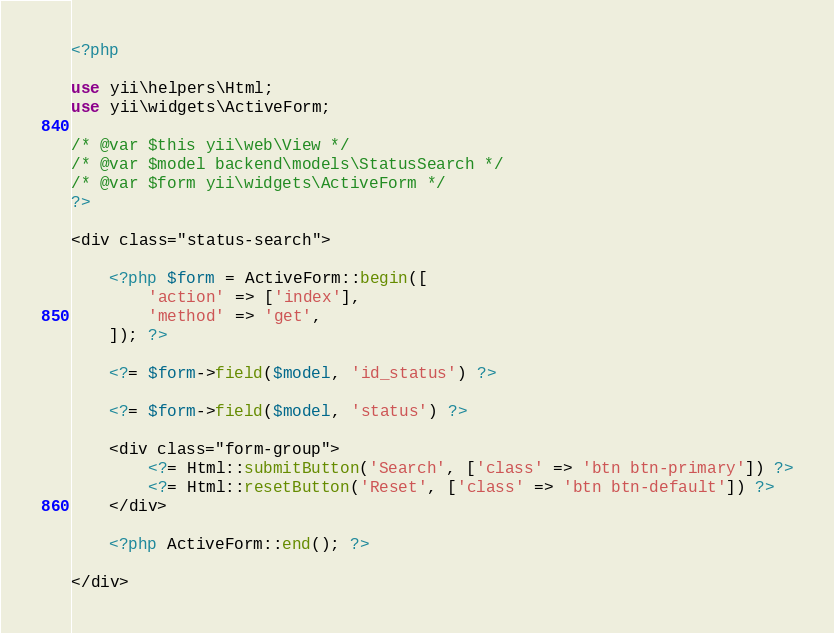Convert code to text. <code><loc_0><loc_0><loc_500><loc_500><_PHP_><?php

use yii\helpers\Html;
use yii\widgets\ActiveForm;

/* @var $this yii\web\View */
/* @var $model backend\models\StatusSearch */
/* @var $form yii\widgets\ActiveForm */
?>

<div class="status-search">

    <?php $form = ActiveForm::begin([
        'action' => ['index'],
        'method' => 'get',
    ]); ?>

    <?= $form->field($model, 'id_status') ?>

    <?= $form->field($model, 'status') ?>

    <div class="form-group">
        <?= Html::submitButton('Search', ['class' => 'btn btn-primary']) ?>
        <?= Html::resetButton('Reset', ['class' => 'btn btn-default']) ?>
    </div>

    <?php ActiveForm::end(); ?>

</div>
</code> 